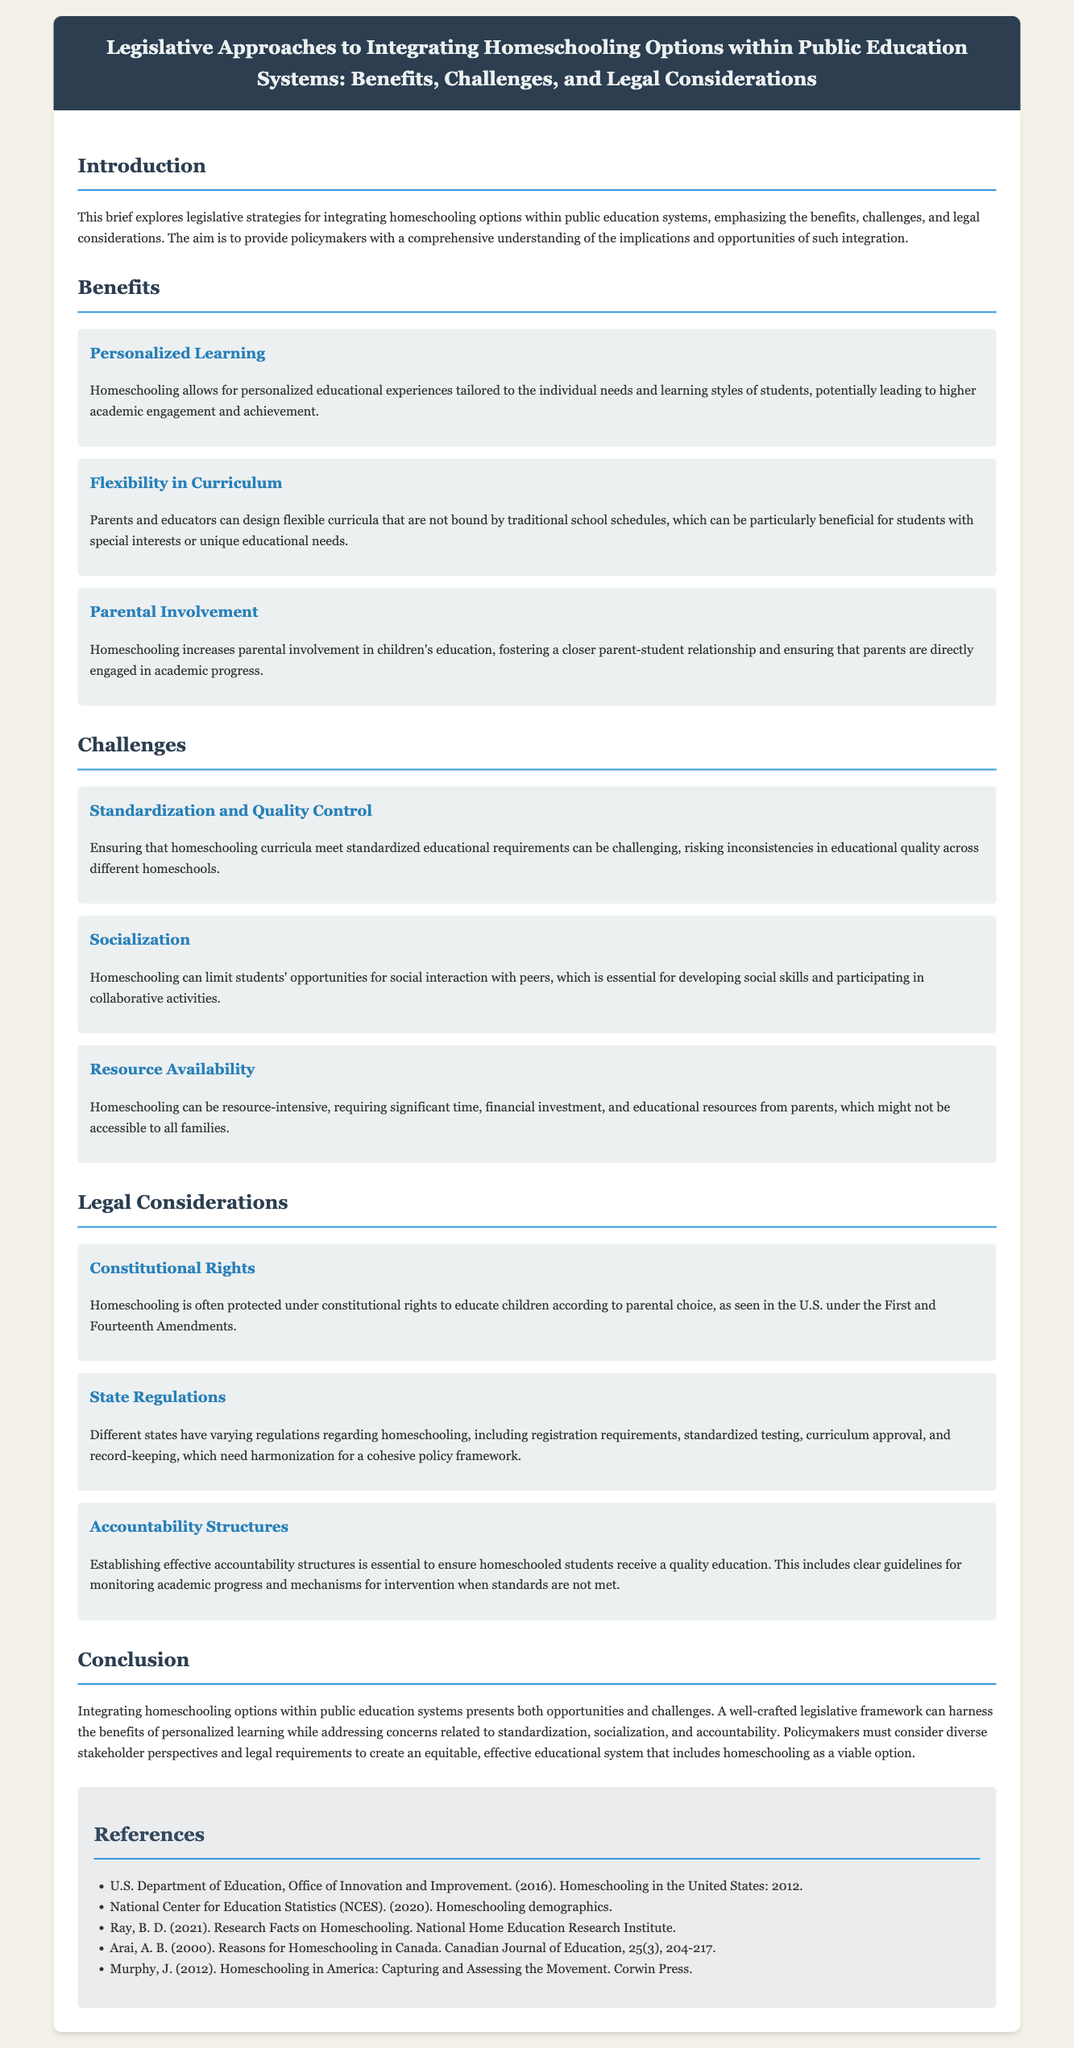What is the primary focus of the brief? The brief primarily focuses on legislative strategies for integrating homeschooling options within public education systems.
Answer: Legislative strategies for integrating homeschooling options What benefit does personalized learning provide? Personalized learning is tailored to the individual needs and learning styles of students, potentially leading to higher academic engagement and achievement.
Answer: Higher academic engagement and achievement What challenge does standardization present? Ensuring that homeschooling curricula meet standardized educational requirements can be challenging, risking inconsistencies in educational quality.
Answer: Inconsistencies in educational quality Which constitutional rights are relevant to homeschooling? Homeschooling is protected under constitutional rights to educate children according to parental choice, particularly the First and Fourteenth Amendments.
Answer: First and Fourteenth Amendments What must policymakers consider for effective integration of homeschooling? Policymakers must consider diverse stakeholder perspectives and legal requirements for creating an equitable educational system.
Answer: Diverse stakeholder perspectives and legal requirements What is essential for ensuring educational quality in homeschooling? Establishing effective accountability structures is essential to ensure homeschooled students receive a quality education.
Answer: Effective accountability structures How many references are listed in the document? The document lists five references.
Answer: Five references What is one benefit of increased parental involvement? Increased parental involvement fosters a closer parent-student relationship and ensures direct engagement in academic progress.
Answer: Closer parent-student relationship What does the conclusion suggest regarding legislative framework? A well-crafted legislative framework can harness the benefits of personalized learning while addressing concerns related to standardization, socialization, and accountability.
Answer: Harness the benefits of personalized learning 